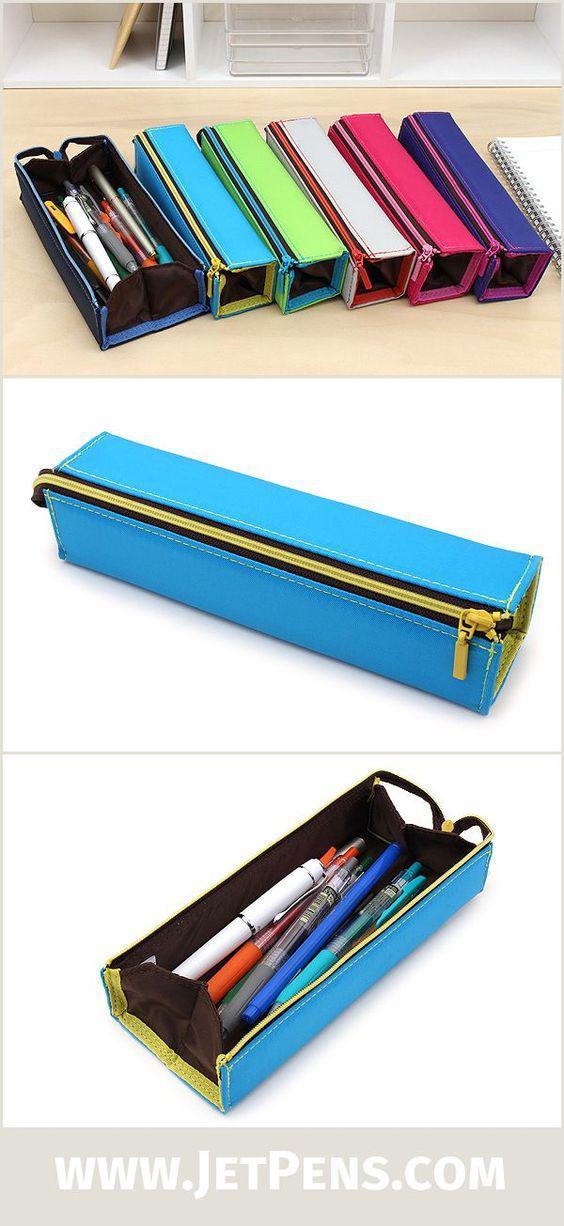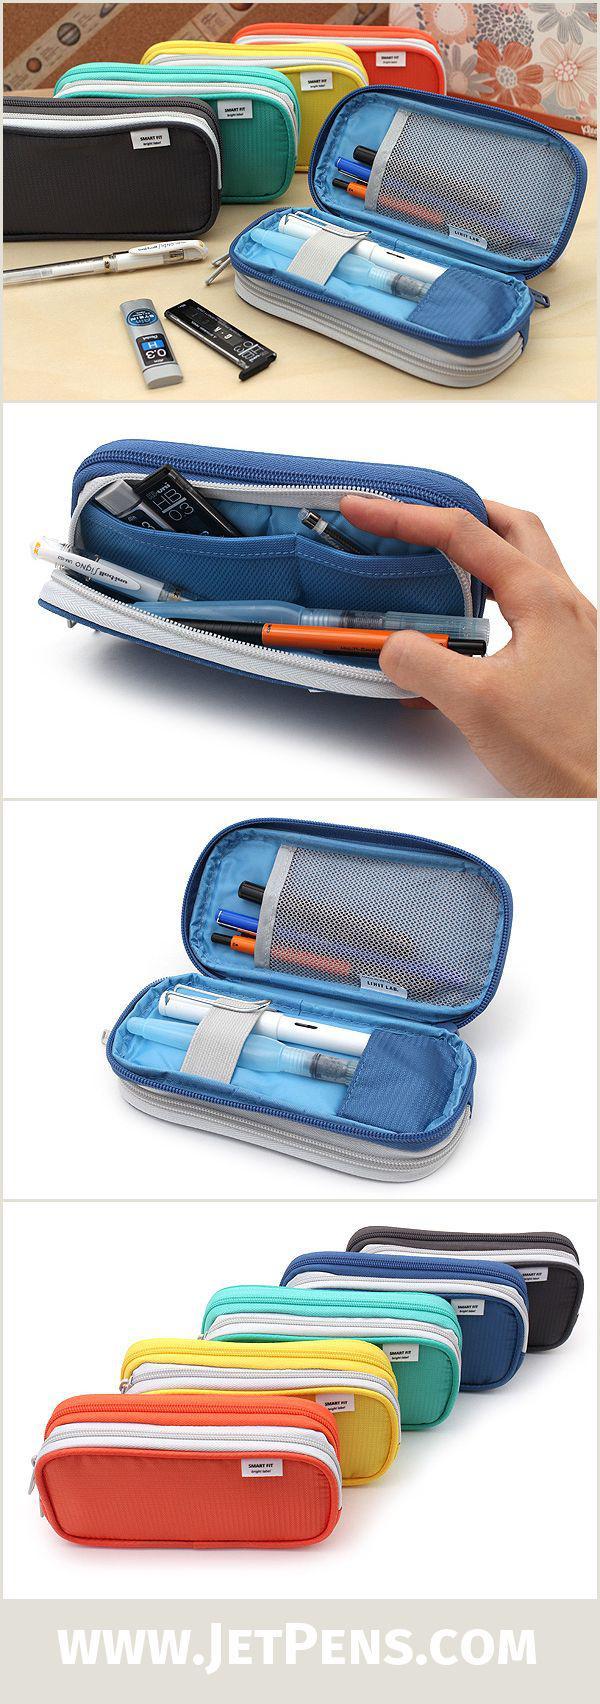The first image is the image on the left, the second image is the image on the right. For the images shown, is this caption "Each image includes a single pencil case, and the left image shows an open case filled with writing implements." true? Answer yes or no. No. 